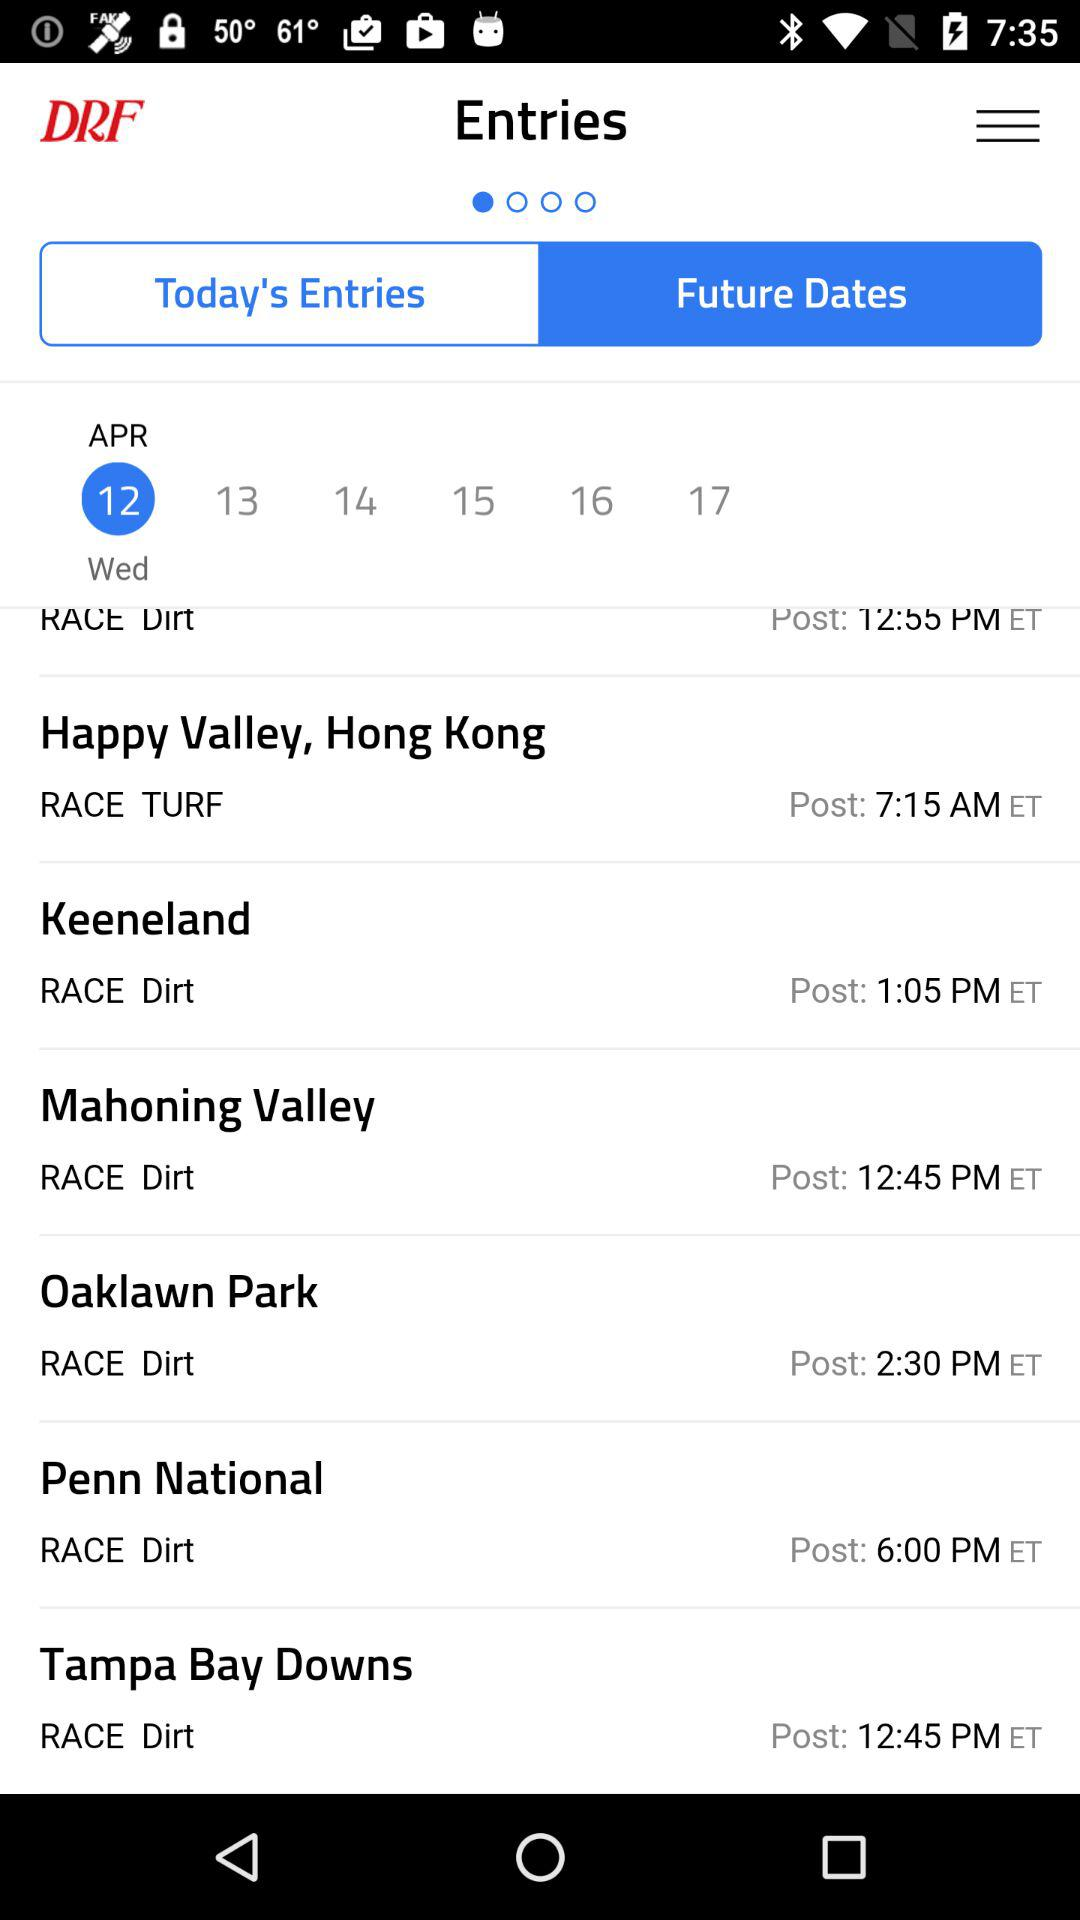What is the selected date? The selected date is Wednesday, April 12. 